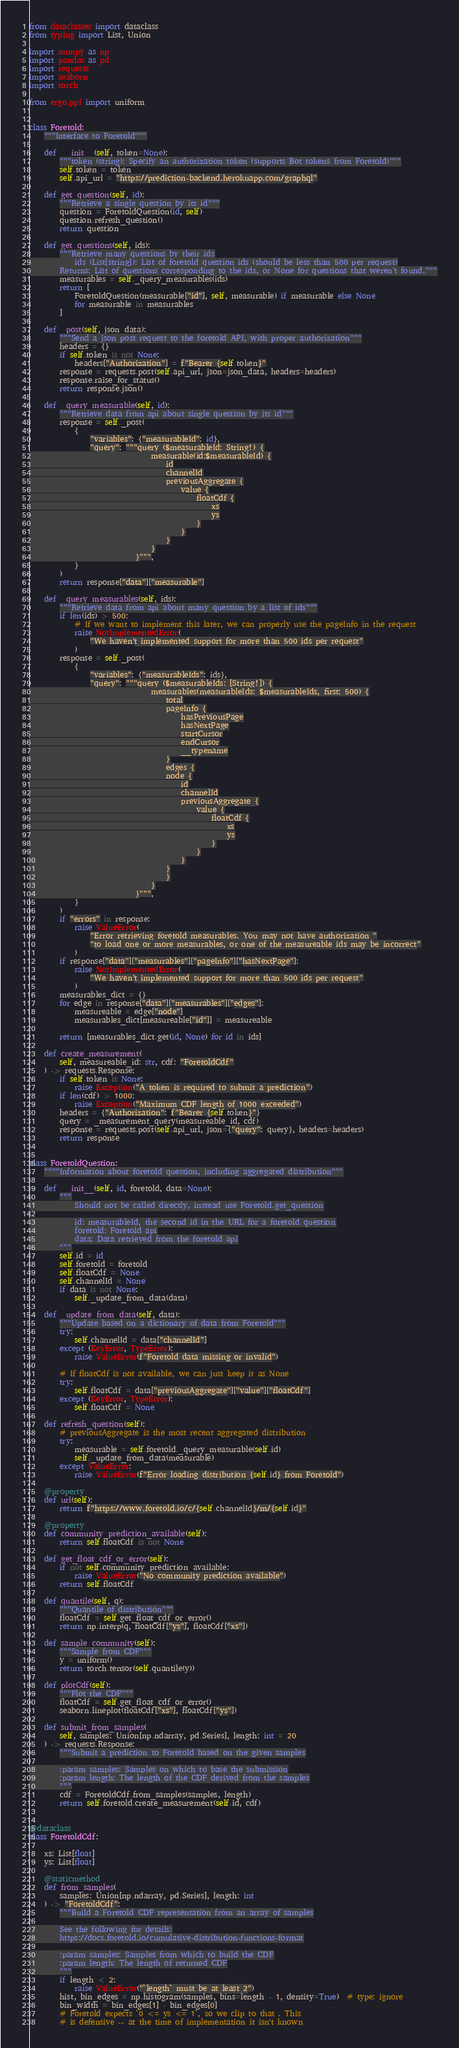<code> <loc_0><loc_0><loc_500><loc_500><_Python_>from dataclasses import dataclass
from typing import List, Union

import numpy as np
import pandas as pd
import requests
import seaborn
import torch

from ergo.ppl import uniform


class Foretold:
    """Interface to Foretold"""

    def __init__(self, token=None):
        """token (string): Specify an authorization token (supports Bot tokens from Foretold)"""
        self.token = token
        self.api_url = "https://prediction-backend.herokuapp.com/graphql"

    def get_question(self, id):
        """Retrieve a single question by its id"""
        question = ForetoldQuestion(id, self)
        question.refresh_question()
        return question

    def get_questions(self, ids):
        """Retrieve many questions by their ids
            ids (List[string]): List of foretold question ids (should be less than 500 per request)
        Returns: List of questions corresponding to the ids, or None for questions that weren't found."""
        measurables = self._query_measurables(ids)
        return [
            ForetoldQuestion(measurable["id"], self, measurable) if measurable else None
            for measurable in measurables
        ]

    def _post(self, json_data):
        """Send a json post request to the foretold API, with proper authorization"""
        headers = {}
        if self.token is not None:
            headers["Authorization"] = f"Bearer {self.token}"
        response = requests.post(self.api_url, json=json_data, headers=headers)
        response.raise_for_status()
        return response.json()

    def _query_measurable(self, id):
        """Retrieve data from api about single question by its id"""
        response = self._post(
            {
                "variables": {"measurableId": id},
                "query": """query ($measurableId: String!) {
                                measurable(id:$measurableId) {
                                    id
                                    channelId
                                    previousAggregate {
                                        value {
                                            floatCdf {
                                                xs
                                                ys
                                            }
                                        }
                                    }
                                }
                            }""",
            }
        )
        return response["data"]["measurable"]

    def _query_measurables(self, ids):
        """Retrieve data from api about many question by a list of ids"""
        if len(ids) > 500:
            # If we want to implement this later, we can properly use the pageInfo in the request
            raise NotImplementedError(
                "We haven't implemented support for more than 500 ids per request"
            )
        response = self._post(
            {
                "variables": {"measurableIds": ids},
                "query": """query ($measurableIds: [String!]) {
                                measurables(measurableIds: $measurableIds, first: 500) {
                                    total
                                    pageInfo {
                                        hasPreviousPage
                                        hasNextPage
                                        startCursor
                                        endCursor
                                        __typename
                                    }
                                    edges {
                                    node {
                                        id
                                        channelId
                                        previousAggregate {
                                            value {
                                                floatCdf {
                                                    xs
                                                    ys
                                                }
                                            }
                                        }
                                    }
                                    }
                                }
                            }""",
            }
        )
        if "errors" in response:
            raise ValueError(
                "Error retrieving foretold measurables. You may not have authorization "
                "to load one or more measurables, or one of the measureable ids may be incorrect"
            )
        if response["data"]["measurables"]["pageInfo"]["hasNextPage"]:
            raise NotImplementedError(
                "We haven't implemented support for more than 500 ids per request"
            )
        measurables_dict = {}
        for edge in response["data"]["measurables"]["edges"]:
            measureable = edge["node"]
            measurables_dict[measureable["id"]] = measureable

        return [measurables_dict.get(id, None) for id in ids]

    def create_measurement(
        self, measureable_id: str, cdf: "ForetoldCdf"
    ) -> requests.Response:
        if self.token is None:
            raise Exception("A token is required to submit a prediction")
        if len(cdf) > 1000:
            raise Exception("Maximum CDF length of 1000 exceeded")
        headers = {"Authorization": f"Bearer {self.token}"}
        query = _measurement_query(measureable_id, cdf)
        response = requests.post(self.api_url, json={"query": query}, headers=headers)
        return response


class ForetoldQuestion:
    """"Information about foretold question, including aggregated distribution"""

    def __init__(self, id, foretold, data=None):
        """
            Should not be called directly, instead use Foretold.get_question

            id: measurableId, the second id in the URL for a foretold question
            foretold: Foretold api
            data: Data retrieved from the foretold api
        """
        self.id = id
        self.foretold = foretold
        self.floatCdf = None
        self.channelId = None
        if data is not None:
            self._update_from_data(data)

    def _update_from_data(self, data):
        """Update based on a dictionary of data from Foretold"""
        try:
            self.channelId = data["channelId"]
        except (KeyError, TypeError):
            raise ValueError(f"Foretold data missing or invalid")

        # If floatCdf is not available, we can just keep it as None
        try:
            self.floatCdf = data["previousAggregate"]["value"]["floatCdf"]
        except (KeyError, TypeError):
            self.floatCdf = None

    def refresh_question(self):
        # previousAggregate is the most recent aggregated distribution
        try:
            measurable = self.foretold._query_measurable(self.id)
            self._update_from_data(measurable)
        except ValueError:
            raise ValueError(f"Error loading distribution {self.id} from Foretold")

    @property
    def url(self):
        return f"https://www.foretold.io/c/{self.channelId}/m/{self.id}"

    @property
    def community_prediction_available(self):
        return self.floatCdf is not None

    def get_float_cdf_or_error(self):
        if not self.community_prediction_available:
            raise ValueError("No community prediction available")
        return self.floatCdf

    def quantile(self, q):
        """Quantile of distribution"""
        floatCdf = self.get_float_cdf_or_error()
        return np.interp(q, floatCdf["ys"], floatCdf["xs"])

    def sample_community(self):
        """Sample from CDF"""
        y = uniform()
        return torch.tensor(self.quantile(y))

    def plotCdf(self):
        """Plot the CDF"""
        floatCdf = self.get_float_cdf_or_error()
        seaborn.lineplot(floatCdf["xs"], floatCdf["ys"])

    def submit_from_samples(
        self, samples: Union[np.ndarray, pd.Series], length: int = 20
    ) -> requests.Response:
        """Submit a prediction to Foretold based on the given samples

        :param samples: Samples on which to base the submission
        :param length: The length of the CDF derived from the samples
        """
        cdf = ForetoldCdf.from_samples(samples, length)
        return self.foretold.create_measurement(self.id, cdf)


@dataclass
class ForetoldCdf:

    xs: List[float]
    ys: List[float]

    @staticmethod
    def from_samples(
        samples: Union[np.ndarray, pd.Series], length: int
    ) -> "ForetoldCdf":
        """Build a Foretold CDF representation from an array of samples

        See the following for details:
        https://docs.foretold.io/cumulative-distribution-functions-format

        :param samples: Samples from which to build the CDF
        :param length: The length of returned CDF
        """
        if length < 2:
            raise ValueError("`length` must be at least 2")
        hist, bin_edges = np.histogram(samples, bins=length - 1, density=True)  # type: ignore
        bin_width = bin_edges[1] - bin_edges[0]
        # Foretold expects `0 <= ys <= 1`, so we clip to that . This
        # is defensive -- at the time of implementation it isn't known</code> 